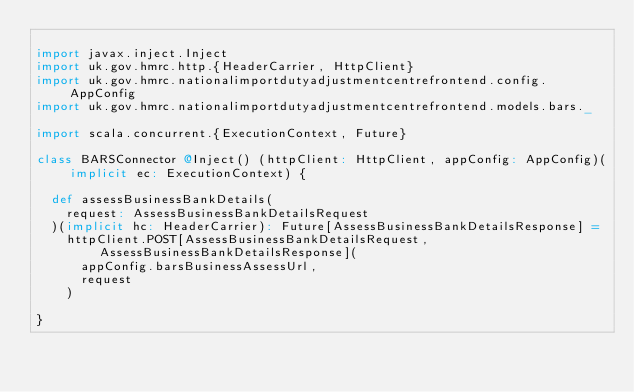Convert code to text. <code><loc_0><loc_0><loc_500><loc_500><_Scala_>
import javax.inject.Inject
import uk.gov.hmrc.http.{HeaderCarrier, HttpClient}
import uk.gov.hmrc.nationalimportdutyadjustmentcentrefrontend.config.AppConfig
import uk.gov.hmrc.nationalimportdutyadjustmentcentrefrontend.models.bars._

import scala.concurrent.{ExecutionContext, Future}

class BARSConnector @Inject() (httpClient: HttpClient, appConfig: AppConfig)(implicit ec: ExecutionContext) {

  def assessBusinessBankDetails(
    request: AssessBusinessBankDetailsRequest
  )(implicit hc: HeaderCarrier): Future[AssessBusinessBankDetailsResponse] =
    httpClient.POST[AssessBusinessBankDetailsRequest, AssessBusinessBankDetailsResponse](
      appConfig.barsBusinessAssessUrl,
      request
    )

}
</code> 